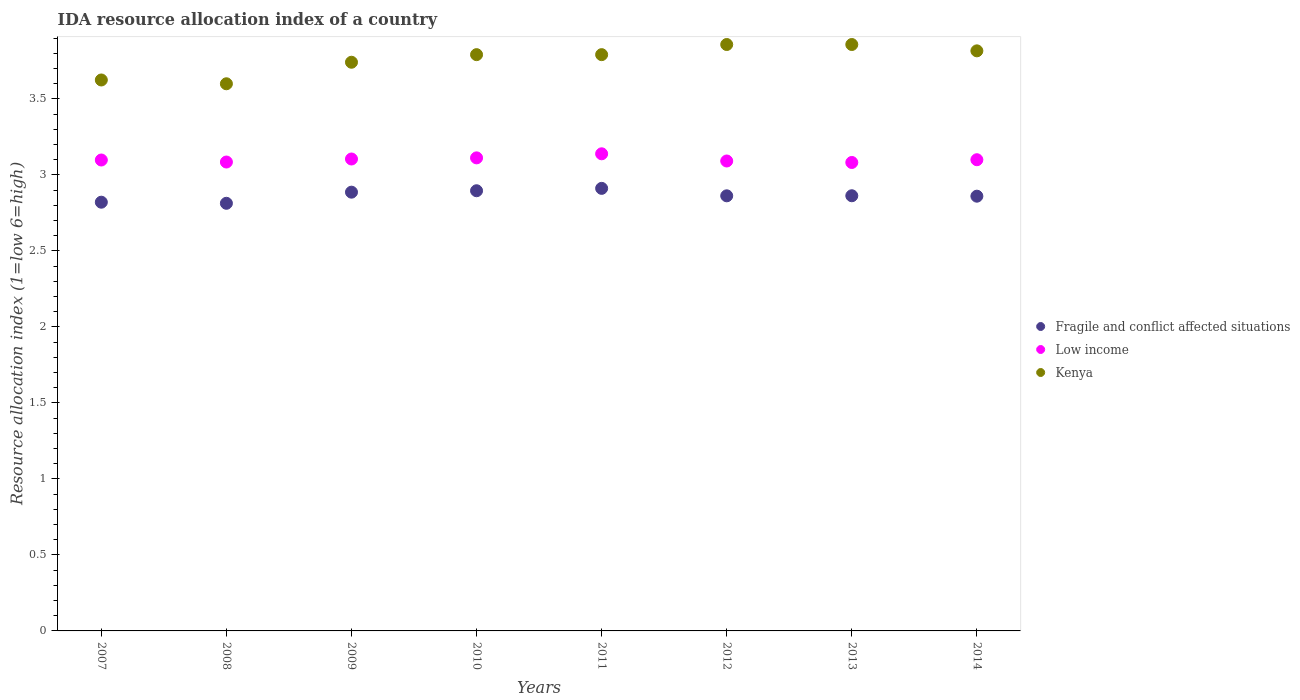How many different coloured dotlines are there?
Keep it short and to the point. 3. What is the IDA resource allocation index in Fragile and conflict affected situations in 2010?
Make the answer very short. 2.9. Across all years, what is the maximum IDA resource allocation index in Low income?
Keep it short and to the point. 3.14. Across all years, what is the minimum IDA resource allocation index in Low income?
Your answer should be compact. 3.08. In which year was the IDA resource allocation index in Kenya maximum?
Offer a terse response. 2012. In which year was the IDA resource allocation index in Kenya minimum?
Offer a terse response. 2008. What is the total IDA resource allocation index in Kenya in the graph?
Provide a short and direct response. 30.08. What is the difference between the IDA resource allocation index in Low income in 2008 and that in 2014?
Your answer should be very brief. -0.02. What is the difference between the IDA resource allocation index in Fragile and conflict affected situations in 2014 and the IDA resource allocation index in Kenya in 2012?
Make the answer very short. -1. What is the average IDA resource allocation index in Low income per year?
Keep it short and to the point. 3.1. In the year 2013, what is the difference between the IDA resource allocation index in Low income and IDA resource allocation index in Fragile and conflict affected situations?
Ensure brevity in your answer.  0.22. What is the ratio of the IDA resource allocation index in Kenya in 2009 to that in 2012?
Give a very brief answer. 0.97. What is the difference between the highest and the second highest IDA resource allocation index in Fragile and conflict affected situations?
Give a very brief answer. 0.02. What is the difference between the highest and the lowest IDA resource allocation index in Fragile and conflict affected situations?
Your answer should be very brief. 0.1. Is the sum of the IDA resource allocation index in Fragile and conflict affected situations in 2007 and 2013 greater than the maximum IDA resource allocation index in Kenya across all years?
Keep it short and to the point. Yes. Does the IDA resource allocation index in Fragile and conflict affected situations monotonically increase over the years?
Your response must be concise. No. Is the IDA resource allocation index in Fragile and conflict affected situations strictly greater than the IDA resource allocation index in Low income over the years?
Offer a very short reply. No. Is the IDA resource allocation index in Low income strictly less than the IDA resource allocation index in Kenya over the years?
Give a very brief answer. Yes. How many years are there in the graph?
Keep it short and to the point. 8. What is the difference between two consecutive major ticks on the Y-axis?
Your answer should be very brief. 0.5. Are the values on the major ticks of Y-axis written in scientific E-notation?
Provide a succinct answer. No. Does the graph contain any zero values?
Your answer should be very brief. No. Where does the legend appear in the graph?
Offer a terse response. Center right. What is the title of the graph?
Offer a terse response. IDA resource allocation index of a country. Does "Lesotho" appear as one of the legend labels in the graph?
Provide a succinct answer. No. What is the label or title of the X-axis?
Your response must be concise. Years. What is the label or title of the Y-axis?
Offer a terse response. Resource allocation index (1=low 6=high). What is the Resource allocation index (1=low 6=high) of Fragile and conflict affected situations in 2007?
Your answer should be very brief. 2.82. What is the Resource allocation index (1=low 6=high) in Low income in 2007?
Offer a very short reply. 3.1. What is the Resource allocation index (1=low 6=high) in Kenya in 2007?
Keep it short and to the point. 3.62. What is the Resource allocation index (1=low 6=high) of Fragile and conflict affected situations in 2008?
Offer a very short reply. 2.81. What is the Resource allocation index (1=low 6=high) in Low income in 2008?
Provide a short and direct response. 3.09. What is the Resource allocation index (1=low 6=high) of Fragile and conflict affected situations in 2009?
Keep it short and to the point. 2.89. What is the Resource allocation index (1=low 6=high) of Low income in 2009?
Make the answer very short. 3.11. What is the Resource allocation index (1=low 6=high) of Kenya in 2009?
Provide a succinct answer. 3.74. What is the Resource allocation index (1=low 6=high) of Fragile and conflict affected situations in 2010?
Ensure brevity in your answer.  2.9. What is the Resource allocation index (1=low 6=high) of Low income in 2010?
Provide a short and direct response. 3.11. What is the Resource allocation index (1=low 6=high) of Kenya in 2010?
Offer a terse response. 3.79. What is the Resource allocation index (1=low 6=high) in Fragile and conflict affected situations in 2011?
Give a very brief answer. 2.91. What is the Resource allocation index (1=low 6=high) of Low income in 2011?
Make the answer very short. 3.14. What is the Resource allocation index (1=low 6=high) of Kenya in 2011?
Your response must be concise. 3.79. What is the Resource allocation index (1=low 6=high) in Fragile and conflict affected situations in 2012?
Provide a short and direct response. 2.86. What is the Resource allocation index (1=low 6=high) of Low income in 2012?
Keep it short and to the point. 3.09. What is the Resource allocation index (1=low 6=high) in Kenya in 2012?
Offer a very short reply. 3.86. What is the Resource allocation index (1=low 6=high) in Fragile and conflict affected situations in 2013?
Keep it short and to the point. 2.86. What is the Resource allocation index (1=low 6=high) of Low income in 2013?
Provide a succinct answer. 3.08. What is the Resource allocation index (1=low 6=high) of Kenya in 2013?
Your response must be concise. 3.86. What is the Resource allocation index (1=low 6=high) of Fragile and conflict affected situations in 2014?
Keep it short and to the point. 2.86. What is the Resource allocation index (1=low 6=high) in Low income in 2014?
Your answer should be compact. 3.1. What is the Resource allocation index (1=low 6=high) of Kenya in 2014?
Give a very brief answer. 3.82. Across all years, what is the maximum Resource allocation index (1=low 6=high) in Fragile and conflict affected situations?
Offer a very short reply. 2.91. Across all years, what is the maximum Resource allocation index (1=low 6=high) in Low income?
Provide a succinct answer. 3.14. Across all years, what is the maximum Resource allocation index (1=low 6=high) in Kenya?
Your answer should be compact. 3.86. Across all years, what is the minimum Resource allocation index (1=low 6=high) of Fragile and conflict affected situations?
Give a very brief answer. 2.81. Across all years, what is the minimum Resource allocation index (1=low 6=high) of Low income?
Keep it short and to the point. 3.08. What is the total Resource allocation index (1=low 6=high) in Fragile and conflict affected situations in the graph?
Provide a short and direct response. 22.92. What is the total Resource allocation index (1=low 6=high) in Low income in the graph?
Keep it short and to the point. 24.81. What is the total Resource allocation index (1=low 6=high) of Kenya in the graph?
Your response must be concise. 30.08. What is the difference between the Resource allocation index (1=low 6=high) of Fragile and conflict affected situations in 2007 and that in 2008?
Offer a very short reply. 0.01. What is the difference between the Resource allocation index (1=low 6=high) of Low income in 2007 and that in 2008?
Your response must be concise. 0.01. What is the difference between the Resource allocation index (1=low 6=high) of Kenya in 2007 and that in 2008?
Your response must be concise. 0.03. What is the difference between the Resource allocation index (1=low 6=high) in Fragile and conflict affected situations in 2007 and that in 2009?
Keep it short and to the point. -0.07. What is the difference between the Resource allocation index (1=low 6=high) of Low income in 2007 and that in 2009?
Provide a short and direct response. -0.01. What is the difference between the Resource allocation index (1=low 6=high) in Kenya in 2007 and that in 2009?
Your answer should be very brief. -0.12. What is the difference between the Resource allocation index (1=low 6=high) in Fragile and conflict affected situations in 2007 and that in 2010?
Provide a short and direct response. -0.08. What is the difference between the Resource allocation index (1=low 6=high) in Low income in 2007 and that in 2010?
Your answer should be compact. -0.01. What is the difference between the Resource allocation index (1=low 6=high) of Kenya in 2007 and that in 2010?
Ensure brevity in your answer.  -0.17. What is the difference between the Resource allocation index (1=low 6=high) in Fragile and conflict affected situations in 2007 and that in 2011?
Your answer should be compact. -0.09. What is the difference between the Resource allocation index (1=low 6=high) of Low income in 2007 and that in 2011?
Provide a short and direct response. -0.04. What is the difference between the Resource allocation index (1=low 6=high) of Fragile and conflict affected situations in 2007 and that in 2012?
Provide a succinct answer. -0.04. What is the difference between the Resource allocation index (1=low 6=high) in Low income in 2007 and that in 2012?
Your answer should be very brief. 0.01. What is the difference between the Resource allocation index (1=low 6=high) in Kenya in 2007 and that in 2012?
Give a very brief answer. -0.23. What is the difference between the Resource allocation index (1=low 6=high) in Fragile and conflict affected situations in 2007 and that in 2013?
Offer a very short reply. -0.04. What is the difference between the Resource allocation index (1=low 6=high) of Low income in 2007 and that in 2013?
Your response must be concise. 0.02. What is the difference between the Resource allocation index (1=low 6=high) in Kenya in 2007 and that in 2013?
Give a very brief answer. -0.23. What is the difference between the Resource allocation index (1=low 6=high) of Fragile and conflict affected situations in 2007 and that in 2014?
Provide a short and direct response. -0.04. What is the difference between the Resource allocation index (1=low 6=high) of Low income in 2007 and that in 2014?
Offer a terse response. -0. What is the difference between the Resource allocation index (1=low 6=high) in Kenya in 2007 and that in 2014?
Keep it short and to the point. -0.19. What is the difference between the Resource allocation index (1=low 6=high) of Fragile and conflict affected situations in 2008 and that in 2009?
Your answer should be compact. -0.07. What is the difference between the Resource allocation index (1=low 6=high) of Low income in 2008 and that in 2009?
Make the answer very short. -0.02. What is the difference between the Resource allocation index (1=low 6=high) of Kenya in 2008 and that in 2009?
Offer a very short reply. -0.14. What is the difference between the Resource allocation index (1=low 6=high) in Fragile and conflict affected situations in 2008 and that in 2010?
Your answer should be very brief. -0.08. What is the difference between the Resource allocation index (1=low 6=high) in Low income in 2008 and that in 2010?
Offer a very short reply. -0.03. What is the difference between the Resource allocation index (1=low 6=high) in Kenya in 2008 and that in 2010?
Provide a succinct answer. -0.19. What is the difference between the Resource allocation index (1=low 6=high) in Fragile and conflict affected situations in 2008 and that in 2011?
Your answer should be compact. -0.1. What is the difference between the Resource allocation index (1=low 6=high) in Low income in 2008 and that in 2011?
Keep it short and to the point. -0.05. What is the difference between the Resource allocation index (1=low 6=high) in Kenya in 2008 and that in 2011?
Give a very brief answer. -0.19. What is the difference between the Resource allocation index (1=low 6=high) of Fragile and conflict affected situations in 2008 and that in 2012?
Provide a short and direct response. -0.05. What is the difference between the Resource allocation index (1=low 6=high) in Low income in 2008 and that in 2012?
Provide a short and direct response. -0.01. What is the difference between the Resource allocation index (1=low 6=high) in Kenya in 2008 and that in 2012?
Make the answer very short. -0.26. What is the difference between the Resource allocation index (1=low 6=high) of Fragile and conflict affected situations in 2008 and that in 2013?
Keep it short and to the point. -0.05. What is the difference between the Resource allocation index (1=low 6=high) in Low income in 2008 and that in 2013?
Provide a succinct answer. 0. What is the difference between the Resource allocation index (1=low 6=high) in Kenya in 2008 and that in 2013?
Your answer should be compact. -0.26. What is the difference between the Resource allocation index (1=low 6=high) in Fragile and conflict affected situations in 2008 and that in 2014?
Make the answer very short. -0.05. What is the difference between the Resource allocation index (1=low 6=high) of Low income in 2008 and that in 2014?
Provide a succinct answer. -0.02. What is the difference between the Resource allocation index (1=low 6=high) of Kenya in 2008 and that in 2014?
Give a very brief answer. -0.22. What is the difference between the Resource allocation index (1=low 6=high) of Fragile and conflict affected situations in 2009 and that in 2010?
Keep it short and to the point. -0.01. What is the difference between the Resource allocation index (1=low 6=high) of Low income in 2009 and that in 2010?
Offer a terse response. -0.01. What is the difference between the Resource allocation index (1=low 6=high) of Kenya in 2009 and that in 2010?
Your answer should be compact. -0.05. What is the difference between the Resource allocation index (1=low 6=high) in Fragile and conflict affected situations in 2009 and that in 2011?
Keep it short and to the point. -0.03. What is the difference between the Resource allocation index (1=low 6=high) of Low income in 2009 and that in 2011?
Offer a very short reply. -0.03. What is the difference between the Resource allocation index (1=low 6=high) in Kenya in 2009 and that in 2011?
Give a very brief answer. -0.05. What is the difference between the Resource allocation index (1=low 6=high) of Fragile and conflict affected situations in 2009 and that in 2012?
Your answer should be compact. 0.02. What is the difference between the Resource allocation index (1=low 6=high) of Low income in 2009 and that in 2012?
Provide a succinct answer. 0.01. What is the difference between the Resource allocation index (1=low 6=high) in Kenya in 2009 and that in 2012?
Your response must be concise. -0.12. What is the difference between the Resource allocation index (1=low 6=high) in Fragile and conflict affected situations in 2009 and that in 2013?
Offer a terse response. 0.02. What is the difference between the Resource allocation index (1=low 6=high) of Low income in 2009 and that in 2013?
Your answer should be compact. 0.02. What is the difference between the Resource allocation index (1=low 6=high) of Kenya in 2009 and that in 2013?
Your response must be concise. -0.12. What is the difference between the Resource allocation index (1=low 6=high) of Fragile and conflict affected situations in 2009 and that in 2014?
Offer a terse response. 0.03. What is the difference between the Resource allocation index (1=low 6=high) of Low income in 2009 and that in 2014?
Make the answer very short. 0. What is the difference between the Resource allocation index (1=low 6=high) of Kenya in 2009 and that in 2014?
Offer a terse response. -0.07. What is the difference between the Resource allocation index (1=low 6=high) in Fragile and conflict affected situations in 2010 and that in 2011?
Ensure brevity in your answer.  -0.02. What is the difference between the Resource allocation index (1=low 6=high) in Low income in 2010 and that in 2011?
Make the answer very short. -0.03. What is the difference between the Resource allocation index (1=low 6=high) of Fragile and conflict affected situations in 2010 and that in 2012?
Give a very brief answer. 0.03. What is the difference between the Resource allocation index (1=low 6=high) of Low income in 2010 and that in 2012?
Provide a succinct answer. 0.02. What is the difference between the Resource allocation index (1=low 6=high) in Kenya in 2010 and that in 2012?
Provide a succinct answer. -0.07. What is the difference between the Resource allocation index (1=low 6=high) of Fragile and conflict affected situations in 2010 and that in 2013?
Keep it short and to the point. 0.03. What is the difference between the Resource allocation index (1=low 6=high) of Low income in 2010 and that in 2013?
Offer a terse response. 0.03. What is the difference between the Resource allocation index (1=low 6=high) of Kenya in 2010 and that in 2013?
Ensure brevity in your answer.  -0.07. What is the difference between the Resource allocation index (1=low 6=high) of Fragile and conflict affected situations in 2010 and that in 2014?
Your response must be concise. 0.04. What is the difference between the Resource allocation index (1=low 6=high) of Low income in 2010 and that in 2014?
Make the answer very short. 0.01. What is the difference between the Resource allocation index (1=low 6=high) in Kenya in 2010 and that in 2014?
Make the answer very short. -0.03. What is the difference between the Resource allocation index (1=low 6=high) in Fragile and conflict affected situations in 2011 and that in 2012?
Keep it short and to the point. 0.05. What is the difference between the Resource allocation index (1=low 6=high) in Low income in 2011 and that in 2012?
Offer a very short reply. 0.05. What is the difference between the Resource allocation index (1=low 6=high) in Kenya in 2011 and that in 2012?
Offer a terse response. -0.07. What is the difference between the Resource allocation index (1=low 6=high) of Fragile and conflict affected situations in 2011 and that in 2013?
Provide a short and direct response. 0.05. What is the difference between the Resource allocation index (1=low 6=high) in Low income in 2011 and that in 2013?
Your response must be concise. 0.06. What is the difference between the Resource allocation index (1=low 6=high) of Kenya in 2011 and that in 2013?
Offer a very short reply. -0.07. What is the difference between the Resource allocation index (1=low 6=high) of Fragile and conflict affected situations in 2011 and that in 2014?
Offer a terse response. 0.05. What is the difference between the Resource allocation index (1=low 6=high) in Low income in 2011 and that in 2014?
Your answer should be compact. 0.04. What is the difference between the Resource allocation index (1=low 6=high) of Kenya in 2011 and that in 2014?
Keep it short and to the point. -0.03. What is the difference between the Resource allocation index (1=low 6=high) of Fragile and conflict affected situations in 2012 and that in 2013?
Offer a terse response. -0. What is the difference between the Resource allocation index (1=low 6=high) in Low income in 2012 and that in 2013?
Give a very brief answer. 0.01. What is the difference between the Resource allocation index (1=low 6=high) in Kenya in 2012 and that in 2013?
Give a very brief answer. 0. What is the difference between the Resource allocation index (1=low 6=high) in Fragile and conflict affected situations in 2012 and that in 2014?
Provide a short and direct response. 0. What is the difference between the Resource allocation index (1=low 6=high) of Low income in 2012 and that in 2014?
Keep it short and to the point. -0.01. What is the difference between the Resource allocation index (1=low 6=high) in Kenya in 2012 and that in 2014?
Make the answer very short. 0.04. What is the difference between the Resource allocation index (1=low 6=high) in Fragile and conflict affected situations in 2013 and that in 2014?
Your answer should be compact. 0. What is the difference between the Resource allocation index (1=low 6=high) in Low income in 2013 and that in 2014?
Provide a succinct answer. -0.02. What is the difference between the Resource allocation index (1=low 6=high) in Kenya in 2013 and that in 2014?
Provide a short and direct response. 0.04. What is the difference between the Resource allocation index (1=low 6=high) of Fragile and conflict affected situations in 2007 and the Resource allocation index (1=low 6=high) of Low income in 2008?
Make the answer very short. -0.26. What is the difference between the Resource allocation index (1=low 6=high) of Fragile and conflict affected situations in 2007 and the Resource allocation index (1=low 6=high) of Kenya in 2008?
Offer a very short reply. -0.78. What is the difference between the Resource allocation index (1=low 6=high) in Low income in 2007 and the Resource allocation index (1=low 6=high) in Kenya in 2008?
Provide a short and direct response. -0.5. What is the difference between the Resource allocation index (1=low 6=high) in Fragile and conflict affected situations in 2007 and the Resource allocation index (1=low 6=high) in Low income in 2009?
Ensure brevity in your answer.  -0.28. What is the difference between the Resource allocation index (1=low 6=high) in Fragile and conflict affected situations in 2007 and the Resource allocation index (1=low 6=high) in Kenya in 2009?
Keep it short and to the point. -0.92. What is the difference between the Resource allocation index (1=low 6=high) in Low income in 2007 and the Resource allocation index (1=low 6=high) in Kenya in 2009?
Give a very brief answer. -0.64. What is the difference between the Resource allocation index (1=low 6=high) of Fragile and conflict affected situations in 2007 and the Resource allocation index (1=low 6=high) of Low income in 2010?
Make the answer very short. -0.29. What is the difference between the Resource allocation index (1=low 6=high) of Fragile and conflict affected situations in 2007 and the Resource allocation index (1=low 6=high) of Kenya in 2010?
Offer a very short reply. -0.97. What is the difference between the Resource allocation index (1=low 6=high) in Low income in 2007 and the Resource allocation index (1=low 6=high) in Kenya in 2010?
Provide a succinct answer. -0.69. What is the difference between the Resource allocation index (1=low 6=high) of Fragile and conflict affected situations in 2007 and the Resource allocation index (1=low 6=high) of Low income in 2011?
Keep it short and to the point. -0.32. What is the difference between the Resource allocation index (1=low 6=high) in Fragile and conflict affected situations in 2007 and the Resource allocation index (1=low 6=high) in Kenya in 2011?
Make the answer very short. -0.97. What is the difference between the Resource allocation index (1=low 6=high) of Low income in 2007 and the Resource allocation index (1=low 6=high) of Kenya in 2011?
Keep it short and to the point. -0.69. What is the difference between the Resource allocation index (1=low 6=high) in Fragile and conflict affected situations in 2007 and the Resource allocation index (1=low 6=high) in Low income in 2012?
Provide a short and direct response. -0.27. What is the difference between the Resource allocation index (1=low 6=high) in Fragile and conflict affected situations in 2007 and the Resource allocation index (1=low 6=high) in Kenya in 2012?
Offer a very short reply. -1.04. What is the difference between the Resource allocation index (1=low 6=high) in Low income in 2007 and the Resource allocation index (1=low 6=high) in Kenya in 2012?
Your answer should be very brief. -0.76. What is the difference between the Resource allocation index (1=low 6=high) in Fragile and conflict affected situations in 2007 and the Resource allocation index (1=low 6=high) in Low income in 2013?
Provide a succinct answer. -0.26. What is the difference between the Resource allocation index (1=low 6=high) of Fragile and conflict affected situations in 2007 and the Resource allocation index (1=low 6=high) of Kenya in 2013?
Keep it short and to the point. -1.04. What is the difference between the Resource allocation index (1=low 6=high) in Low income in 2007 and the Resource allocation index (1=low 6=high) in Kenya in 2013?
Keep it short and to the point. -0.76. What is the difference between the Resource allocation index (1=low 6=high) in Fragile and conflict affected situations in 2007 and the Resource allocation index (1=low 6=high) in Low income in 2014?
Ensure brevity in your answer.  -0.28. What is the difference between the Resource allocation index (1=low 6=high) in Fragile and conflict affected situations in 2007 and the Resource allocation index (1=low 6=high) in Kenya in 2014?
Provide a short and direct response. -1. What is the difference between the Resource allocation index (1=low 6=high) in Low income in 2007 and the Resource allocation index (1=low 6=high) in Kenya in 2014?
Your response must be concise. -0.72. What is the difference between the Resource allocation index (1=low 6=high) of Fragile and conflict affected situations in 2008 and the Resource allocation index (1=low 6=high) of Low income in 2009?
Offer a terse response. -0.29. What is the difference between the Resource allocation index (1=low 6=high) of Fragile and conflict affected situations in 2008 and the Resource allocation index (1=low 6=high) of Kenya in 2009?
Your answer should be compact. -0.93. What is the difference between the Resource allocation index (1=low 6=high) in Low income in 2008 and the Resource allocation index (1=low 6=high) in Kenya in 2009?
Your answer should be compact. -0.66. What is the difference between the Resource allocation index (1=low 6=high) of Fragile and conflict affected situations in 2008 and the Resource allocation index (1=low 6=high) of Low income in 2010?
Your answer should be compact. -0.3. What is the difference between the Resource allocation index (1=low 6=high) of Fragile and conflict affected situations in 2008 and the Resource allocation index (1=low 6=high) of Kenya in 2010?
Keep it short and to the point. -0.98. What is the difference between the Resource allocation index (1=low 6=high) of Low income in 2008 and the Resource allocation index (1=low 6=high) of Kenya in 2010?
Offer a very short reply. -0.71. What is the difference between the Resource allocation index (1=low 6=high) in Fragile and conflict affected situations in 2008 and the Resource allocation index (1=low 6=high) in Low income in 2011?
Offer a very short reply. -0.33. What is the difference between the Resource allocation index (1=low 6=high) of Fragile and conflict affected situations in 2008 and the Resource allocation index (1=low 6=high) of Kenya in 2011?
Give a very brief answer. -0.98. What is the difference between the Resource allocation index (1=low 6=high) of Low income in 2008 and the Resource allocation index (1=low 6=high) of Kenya in 2011?
Provide a short and direct response. -0.71. What is the difference between the Resource allocation index (1=low 6=high) of Fragile and conflict affected situations in 2008 and the Resource allocation index (1=low 6=high) of Low income in 2012?
Keep it short and to the point. -0.28. What is the difference between the Resource allocation index (1=low 6=high) in Fragile and conflict affected situations in 2008 and the Resource allocation index (1=low 6=high) in Kenya in 2012?
Keep it short and to the point. -1.04. What is the difference between the Resource allocation index (1=low 6=high) of Low income in 2008 and the Resource allocation index (1=low 6=high) of Kenya in 2012?
Provide a short and direct response. -0.77. What is the difference between the Resource allocation index (1=low 6=high) of Fragile and conflict affected situations in 2008 and the Resource allocation index (1=low 6=high) of Low income in 2013?
Keep it short and to the point. -0.27. What is the difference between the Resource allocation index (1=low 6=high) in Fragile and conflict affected situations in 2008 and the Resource allocation index (1=low 6=high) in Kenya in 2013?
Give a very brief answer. -1.04. What is the difference between the Resource allocation index (1=low 6=high) of Low income in 2008 and the Resource allocation index (1=low 6=high) of Kenya in 2013?
Offer a terse response. -0.77. What is the difference between the Resource allocation index (1=low 6=high) of Fragile and conflict affected situations in 2008 and the Resource allocation index (1=low 6=high) of Low income in 2014?
Provide a succinct answer. -0.29. What is the difference between the Resource allocation index (1=low 6=high) in Fragile and conflict affected situations in 2008 and the Resource allocation index (1=low 6=high) in Kenya in 2014?
Give a very brief answer. -1. What is the difference between the Resource allocation index (1=low 6=high) in Low income in 2008 and the Resource allocation index (1=low 6=high) in Kenya in 2014?
Give a very brief answer. -0.73. What is the difference between the Resource allocation index (1=low 6=high) of Fragile and conflict affected situations in 2009 and the Resource allocation index (1=low 6=high) of Low income in 2010?
Give a very brief answer. -0.23. What is the difference between the Resource allocation index (1=low 6=high) in Fragile and conflict affected situations in 2009 and the Resource allocation index (1=low 6=high) in Kenya in 2010?
Provide a short and direct response. -0.9. What is the difference between the Resource allocation index (1=low 6=high) of Low income in 2009 and the Resource allocation index (1=low 6=high) of Kenya in 2010?
Keep it short and to the point. -0.69. What is the difference between the Resource allocation index (1=low 6=high) of Fragile and conflict affected situations in 2009 and the Resource allocation index (1=low 6=high) of Low income in 2011?
Make the answer very short. -0.25. What is the difference between the Resource allocation index (1=low 6=high) in Fragile and conflict affected situations in 2009 and the Resource allocation index (1=low 6=high) in Kenya in 2011?
Provide a short and direct response. -0.9. What is the difference between the Resource allocation index (1=low 6=high) in Low income in 2009 and the Resource allocation index (1=low 6=high) in Kenya in 2011?
Your answer should be compact. -0.69. What is the difference between the Resource allocation index (1=low 6=high) of Fragile and conflict affected situations in 2009 and the Resource allocation index (1=low 6=high) of Low income in 2012?
Ensure brevity in your answer.  -0.21. What is the difference between the Resource allocation index (1=low 6=high) of Fragile and conflict affected situations in 2009 and the Resource allocation index (1=low 6=high) of Kenya in 2012?
Provide a succinct answer. -0.97. What is the difference between the Resource allocation index (1=low 6=high) of Low income in 2009 and the Resource allocation index (1=low 6=high) of Kenya in 2012?
Offer a very short reply. -0.75. What is the difference between the Resource allocation index (1=low 6=high) of Fragile and conflict affected situations in 2009 and the Resource allocation index (1=low 6=high) of Low income in 2013?
Keep it short and to the point. -0.2. What is the difference between the Resource allocation index (1=low 6=high) of Fragile and conflict affected situations in 2009 and the Resource allocation index (1=low 6=high) of Kenya in 2013?
Your answer should be very brief. -0.97. What is the difference between the Resource allocation index (1=low 6=high) of Low income in 2009 and the Resource allocation index (1=low 6=high) of Kenya in 2013?
Ensure brevity in your answer.  -0.75. What is the difference between the Resource allocation index (1=low 6=high) in Fragile and conflict affected situations in 2009 and the Resource allocation index (1=low 6=high) in Low income in 2014?
Ensure brevity in your answer.  -0.21. What is the difference between the Resource allocation index (1=low 6=high) of Fragile and conflict affected situations in 2009 and the Resource allocation index (1=low 6=high) of Kenya in 2014?
Your response must be concise. -0.93. What is the difference between the Resource allocation index (1=low 6=high) of Low income in 2009 and the Resource allocation index (1=low 6=high) of Kenya in 2014?
Provide a succinct answer. -0.71. What is the difference between the Resource allocation index (1=low 6=high) of Fragile and conflict affected situations in 2010 and the Resource allocation index (1=low 6=high) of Low income in 2011?
Your answer should be very brief. -0.24. What is the difference between the Resource allocation index (1=low 6=high) in Fragile and conflict affected situations in 2010 and the Resource allocation index (1=low 6=high) in Kenya in 2011?
Provide a succinct answer. -0.9. What is the difference between the Resource allocation index (1=low 6=high) of Low income in 2010 and the Resource allocation index (1=low 6=high) of Kenya in 2011?
Your answer should be very brief. -0.68. What is the difference between the Resource allocation index (1=low 6=high) of Fragile and conflict affected situations in 2010 and the Resource allocation index (1=low 6=high) of Low income in 2012?
Provide a succinct answer. -0.2. What is the difference between the Resource allocation index (1=low 6=high) in Fragile and conflict affected situations in 2010 and the Resource allocation index (1=low 6=high) in Kenya in 2012?
Your response must be concise. -0.96. What is the difference between the Resource allocation index (1=low 6=high) of Low income in 2010 and the Resource allocation index (1=low 6=high) of Kenya in 2012?
Provide a short and direct response. -0.75. What is the difference between the Resource allocation index (1=low 6=high) in Fragile and conflict affected situations in 2010 and the Resource allocation index (1=low 6=high) in Low income in 2013?
Keep it short and to the point. -0.19. What is the difference between the Resource allocation index (1=low 6=high) of Fragile and conflict affected situations in 2010 and the Resource allocation index (1=low 6=high) of Kenya in 2013?
Offer a terse response. -0.96. What is the difference between the Resource allocation index (1=low 6=high) in Low income in 2010 and the Resource allocation index (1=low 6=high) in Kenya in 2013?
Offer a terse response. -0.75. What is the difference between the Resource allocation index (1=low 6=high) in Fragile and conflict affected situations in 2010 and the Resource allocation index (1=low 6=high) in Low income in 2014?
Give a very brief answer. -0.2. What is the difference between the Resource allocation index (1=low 6=high) in Fragile and conflict affected situations in 2010 and the Resource allocation index (1=low 6=high) in Kenya in 2014?
Offer a very short reply. -0.92. What is the difference between the Resource allocation index (1=low 6=high) in Low income in 2010 and the Resource allocation index (1=low 6=high) in Kenya in 2014?
Provide a short and direct response. -0.7. What is the difference between the Resource allocation index (1=low 6=high) of Fragile and conflict affected situations in 2011 and the Resource allocation index (1=low 6=high) of Low income in 2012?
Your answer should be compact. -0.18. What is the difference between the Resource allocation index (1=low 6=high) in Fragile and conflict affected situations in 2011 and the Resource allocation index (1=low 6=high) in Kenya in 2012?
Keep it short and to the point. -0.95. What is the difference between the Resource allocation index (1=low 6=high) in Low income in 2011 and the Resource allocation index (1=low 6=high) in Kenya in 2012?
Make the answer very short. -0.72. What is the difference between the Resource allocation index (1=low 6=high) in Fragile and conflict affected situations in 2011 and the Resource allocation index (1=low 6=high) in Low income in 2013?
Offer a terse response. -0.17. What is the difference between the Resource allocation index (1=low 6=high) of Fragile and conflict affected situations in 2011 and the Resource allocation index (1=low 6=high) of Kenya in 2013?
Offer a very short reply. -0.95. What is the difference between the Resource allocation index (1=low 6=high) of Low income in 2011 and the Resource allocation index (1=low 6=high) of Kenya in 2013?
Offer a terse response. -0.72. What is the difference between the Resource allocation index (1=low 6=high) in Fragile and conflict affected situations in 2011 and the Resource allocation index (1=low 6=high) in Low income in 2014?
Your response must be concise. -0.19. What is the difference between the Resource allocation index (1=low 6=high) in Fragile and conflict affected situations in 2011 and the Resource allocation index (1=low 6=high) in Kenya in 2014?
Make the answer very short. -0.9. What is the difference between the Resource allocation index (1=low 6=high) in Low income in 2011 and the Resource allocation index (1=low 6=high) in Kenya in 2014?
Keep it short and to the point. -0.68. What is the difference between the Resource allocation index (1=low 6=high) in Fragile and conflict affected situations in 2012 and the Resource allocation index (1=low 6=high) in Low income in 2013?
Make the answer very short. -0.22. What is the difference between the Resource allocation index (1=low 6=high) in Fragile and conflict affected situations in 2012 and the Resource allocation index (1=low 6=high) in Kenya in 2013?
Your answer should be very brief. -1. What is the difference between the Resource allocation index (1=low 6=high) in Low income in 2012 and the Resource allocation index (1=low 6=high) in Kenya in 2013?
Keep it short and to the point. -0.77. What is the difference between the Resource allocation index (1=low 6=high) of Fragile and conflict affected situations in 2012 and the Resource allocation index (1=low 6=high) of Low income in 2014?
Keep it short and to the point. -0.24. What is the difference between the Resource allocation index (1=low 6=high) of Fragile and conflict affected situations in 2012 and the Resource allocation index (1=low 6=high) of Kenya in 2014?
Offer a very short reply. -0.95. What is the difference between the Resource allocation index (1=low 6=high) in Low income in 2012 and the Resource allocation index (1=low 6=high) in Kenya in 2014?
Make the answer very short. -0.72. What is the difference between the Resource allocation index (1=low 6=high) of Fragile and conflict affected situations in 2013 and the Resource allocation index (1=low 6=high) of Low income in 2014?
Your response must be concise. -0.24. What is the difference between the Resource allocation index (1=low 6=high) of Fragile and conflict affected situations in 2013 and the Resource allocation index (1=low 6=high) of Kenya in 2014?
Your response must be concise. -0.95. What is the difference between the Resource allocation index (1=low 6=high) in Low income in 2013 and the Resource allocation index (1=low 6=high) in Kenya in 2014?
Give a very brief answer. -0.73. What is the average Resource allocation index (1=low 6=high) in Fragile and conflict affected situations per year?
Your answer should be very brief. 2.86. What is the average Resource allocation index (1=low 6=high) in Low income per year?
Your answer should be very brief. 3.1. What is the average Resource allocation index (1=low 6=high) of Kenya per year?
Your answer should be very brief. 3.76. In the year 2007, what is the difference between the Resource allocation index (1=low 6=high) of Fragile and conflict affected situations and Resource allocation index (1=low 6=high) of Low income?
Keep it short and to the point. -0.28. In the year 2007, what is the difference between the Resource allocation index (1=low 6=high) in Fragile and conflict affected situations and Resource allocation index (1=low 6=high) in Kenya?
Give a very brief answer. -0.8. In the year 2007, what is the difference between the Resource allocation index (1=low 6=high) in Low income and Resource allocation index (1=low 6=high) in Kenya?
Ensure brevity in your answer.  -0.53. In the year 2008, what is the difference between the Resource allocation index (1=low 6=high) in Fragile and conflict affected situations and Resource allocation index (1=low 6=high) in Low income?
Give a very brief answer. -0.27. In the year 2008, what is the difference between the Resource allocation index (1=low 6=high) of Fragile and conflict affected situations and Resource allocation index (1=low 6=high) of Kenya?
Your response must be concise. -0.79. In the year 2008, what is the difference between the Resource allocation index (1=low 6=high) in Low income and Resource allocation index (1=low 6=high) in Kenya?
Your answer should be compact. -0.51. In the year 2009, what is the difference between the Resource allocation index (1=low 6=high) of Fragile and conflict affected situations and Resource allocation index (1=low 6=high) of Low income?
Offer a terse response. -0.22. In the year 2009, what is the difference between the Resource allocation index (1=low 6=high) of Fragile and conflict affected situations and Resource allocation index (1=low 6=high) of Kenya?
Your response must be concise. -0.85. In the year 2009, what is the difference between the Resource allocation index (1=low 6=high) in Low income and Resource allocation index (1=low 6=high) in Kenya?
Provide a succinct answer. -0.64. In the year 2010, what is the difference between the Resource allocation index (1=low 6=high) in Fragile and conflict affected situations and Resource allocation index (1=low 6=high) in Low income?
Give a very brief answer. -0.22. In the year 2010, what is the difference between the Resource allocation index (1=low 6=high) of Fragile and conflict affected situations and Resource allocation index (1=low 6=high) of Kenya?
Offer a terse response. -0.9. In the year 2010, what is the difference between the Resource allocation index (1=low 6=high) of Low income and Resource allocation index (1=low 6=high) of Kenya?
Your answer should be very brief. -0.68. In the year 2011, what is the difference between the Resource allocation index (1=low 6=high) in Fragile and conflict affected situations and Resource allocation index (1=low 6=high) in Low income?
Provide a short and direct response. -0.23. In the year 2011, what is the difference between the Resource allocation index (1=low 6=high) in Fragile and conflict affected situations and Resource allocation index (1=low 6=high) in Kenya?
Your answer should be very brief. -0.88. In the year 2011, what is the difference between the Resource allocation index (1=low 6=high) in Low income and Resource allocation index (1=low 6=high) in Kenya?
Ensure brevity in your answer.  -0.65. In the year 2012, what is the difference between the Resource allocation index (1=low 6=high) in Fragile and conflict affected situations and Resource allocation index (1=low 6=high) in Low income?
Your answer should be compact. -0.23. In the year 2012, what is the difference between the Resource allocation index (1=low 6=high) of Fragile and conflict affected situations and Resource allocation index (1=low 6=high) of Kenya?
Your answer should be very brief. -1. In the year 2012, what is the difference between the Resource allocation index (1=low 6=high) of Low income and Resource allocation index (1=low 6=high) of Kenya?
Ensure brevity in your answer.  -0.77. In the year 2013, what is the difference between the Resource allocation index (1=low 6=high) of Fragile and conflict affected situations and Resource allocation index (1=low 6=high) of Low income?
Provide a short and direct response. -0.22. In the year 2013, what is the difference between the Resource allocation index (1=low 6=high) in Fragile and conflict affected situations and Resource allocation index (1=low 6=high) in Kenya?
Keep it short and to the point. -1. In the year 2013, what is the difference between the Resource allocation index (1=low 6=high) in Low income and Resource allocation index (1=low 6=high) in Kenya?
Your answer should be compact. -0.78. In the year 2014, what is the difference between the Resource allocation index (1=low 6=high) of Fragile and conflict affected situations and Resource allocation index (1=low 6=high) of Low income?
Ensure brevity in your answer.  -0.24. In the year 2014, what is the difference between the Resource allocation index (1=low 6=high) in Fragile and conflict affected situations and Resource allocation index (1=low 6=high) in Kenya?
Your answer should be very brief. -0.96. In the year 2014, what is the difference between the Resource allocation index (1=low 6=high) in Low income and Resource allocation index (1=low 6=high) in Kenya?
Give a very brief answer. -0.72. What is the ratio of the Resource allocation index (1=low 6=high) in Fragile and conflict affected situations in 2007 to that in 2009?
Ensure brevity in your answer.  0.98. What is the ratio of the Resource allocation index (1=low 6=high) in Low income in 2007 to that in 2009?
Provide a succinct answer. 1. What is the ratio of the Resource allocation index (1=low 6=high) of Kenya in 2007 to that in 2009?
Ensure brevity in your answer.  0.97. What is the ratio of the Resource allocation index (1=low 6=high) of Low income in 2007 to that in 2010?
Ensure brevity in your answer.  1. What is the ratio of the Resource allocation index (1=low 6=high) in Kenya in 2007 to that in 2010?
Keep it short and to the point. 0.96. What is the ratio of the Resource allocation index (1=low 6=high) of Fragile and conflict affected situations in 2007 to that in 2011?
Offer a terse response. 0.97. What is the ratio of the Resource allocation index (1=low 6=high) in Low income in 2007 to that in 2011?
Provide a succinct answer. 0.99. What is the ratio of the Resource allocation index (1=low 6=high) in Kenya in 2007 to that in 2011?
Your response must be concise. 0.96. What is the ratio of the Resource allocation index (1=low 6=high) in Fragile and conflict affected situations in 2007 to that in 2012?
Your response must be concise. 0.99. What is the ratio of the Resource allocation index (1=low 6=high) of Low income in 2007 to that in 2012?
Ensure brevity in your answer.  1. What is the ratio of the Resource allocation index (1=low 6=high) in Kenya in 2007 to that in 2012?
Offer a terse response. 0.94. What is the ratio of the Resource allocation index (1=low 6=high) of Fragile and conflict affected situations in 2007 to that in 2013?
Offer a very short reply. 0.99. What is the ratio of the Resource allocation index (1=low 6=high) of Low income in 2007 to that in 2013?
Provide a short and direct response. 1.01. What is the ratio of the Resource allocation index (1=low 6=high) in Kenya in 2007 to that in 2013?
Your answer should be very brief. 0.94. What is the ratio of the Resource allocation index (1=low 6=high) of Fragile and conflict affected situations in 2007 to that in 2014?
Provide a succinct answer. 0.99. What is the ratio of the Resource allocation index (1=low 6=high) in Kenya in 2007 to that in 2014?
Your response must be concise. 0.95. What is the ratio of the Resource allocation index (1=low 6=high) in Fragile and conflict affected situations in 2008 to that in 2009?
Provide a short and direct response. 0.97. What is the ratio of the Resource allocation index (1=low 6=high) in Kenya in 2008 to that in 2009?
Your answer should be very brief. 0.96. What is the ratio of the Resource allocation index (1=low 6=high) in Fragile and conflict affected situations in 2008 to that in 2010?
Your answer should be very brief. 0.97. What is the ratio of the Resource allocation index (1=low 6=high) of Low income in 2008 to that in 2010?
Give a very brief answer. 0.99. What is the ratio of the Resource allocation index (1=low 6=high) of Kenya in 2008 to that in 2010?
Keep it short and to the point. 0.95. What is the ratio of the Resource allocation index (1=low 6=high) of Fragile and conflict affected situations in 2008 to that in 2011?
Ensure brevity in your answer.  0.97. What is the ratio of the Resource allocation index (1=low 6=high) of Low income in 2008 to that in 2011?
Make the answer very short. 0.98. What is the ratio of the Resource allocation index (1=low 6=high) of Kenya in 2008 to that in 2011?
Keep it short and to the point. 0.95. What is the ratio of the Resource allocation index (1=low 6=high) of Fragile and conflict affected situations in 2008 to that in 2012?
Your response must be concise. 0.98. What is the ratio of the Resource allocation index (1=low 6=high) of Low income in 2008 to that in 2012?
Offer a very short reply. 1. What is the ratio of the Resource allocation index (1=low 6=high) in Kenya in 2008 to that in 2012?
Your answer should be very brief. 0.93. What is the ratio of the Resource allocation index (1=low 6=high) of Fragile and conflict affected situations in 2008 to that in 2013?
Give a very brief answer. 0.98. What is the ratio of the Resource allocation index (1=low 6=high) of Low income in 2008 to that in 2013?
Your response must be concise. 1. What is the ratio of the Resource allocation index (1=low 6=high) in Kenya in 2008 to that in 2013?
Offer a very short reply. 0.93. What is the ratio of the Resource allocation index (1=low 6=high) of Fragile and conflict affected situations in 2008 to that in 2014?
Make the answer very short. 0.98. What is the ratio of the Resource allocation index (1=low 6=high) of Kenya in 2008 to that in 2014?
Your answer should be compact. 0.94. What is the ratio of the Resource allocation index (1=low 6=high) in Kenya in 2009 to that in 2010?
Your response must be concise. 0.99. What is the ratio of the Resource allocation index (1=low 6=high) of Fragile and conflict affected situations in 2009 to that in 2011?
Make the answer very short. 0.99. What is the ratio of the Resource allocation index (1=low 6=high) of Fragile and conflict affected situations in 2009 to that in 2012?
Make the answer very short. 1.01. What is the ratio of the Resource allocation index (1=low 6=high) of Low income in 2009 to that in 2012?
Your answer should be compact. 1. What is the ratio of the Resource allocation index (1=low 6=high) in Kenya in 2009 to that in 2012?
Ensure brevity in your answer.  0.97. What is the ratio of the Resource allocation index (1=low 6=high) in Fragile and conflict affected situations in 2009 to that in 2013?
Make the answer very short. 1.01. What is the ratio of the Resource allocation index (1=low 6=high) of Low income in 2009 to that in 2013?
Your answer should be compact. 1.01. What is the ratio of the Resource allocation index (1=low 6=high) of Kenya in 2009 to that in 2013?
Provide a succinct answer. 0.97. What is the ratio of the Resource allocation index (1=low 6=high) of Fragile and conflict affected situations in 2009 to that in 2014?
Your response must be concise. 1.01. What is the ratio of the Resource allocation index (1=low 6=high) of Low income in 2009 to that in 2014?
Your response must be concise. 1. What is the ratio of the Resource allocation index (1=low 6=high) in Kenya in 2009 to that in 2014?
Your response must be concise. 0.98. What is the ratio of the Resource allocation index (1=low 6=high) in Fragile and conflict affected situations in 2010 to that in 2011?
Provide a short and direct response. 0.99. What is the ratio of the Resource allocation index (1=low 6=high) of Low income in 2010 to that in 2011?
Give a very brief answer. 0.99. What is the ratio of the Resource allocation index (1=low 6=high) of Kenya in 2010 to that in 2011?
Your response must be concise. 1. What is the ratio of the Resource allocation index (1=low 6=high) of Fragile and conflict affected situations in 2010 to that in 2012?
Make the answer very short. 1.01. What is the ratio of the Resource allocation index (1=low 6=high) in Low income in 2010 to that in 2012?
Offer a terse response. 1.01. What is the ratio of the Resource allocation index (1=low 6=high) in Kenya in 2010 to that in 2012?
Provide a short and direct response. 0.98. What is the ratio of the Resource allocation index (1=low 6=high) of Fragile and conflict affected situations in 2010 to that in 2013?
Provide a succinct answer. 1.01. What is the ratio of the Resource allocation index (1=low 6=high) in Low income in 2010 to that in 2013?
Make the answer very short. 1.01. What is the ratio of the Resource allocation index (1=low 6=high) of Kenya in 2010 to that in 2013?
Provide a short and direct response. 0.98. What is the ratio of the Resource allocation index (1=low 6=high) in Fragile and conflict affected situations in 2010 to that in 2014?
Provide a succinct answer. 1.01. What is the ratio of the Resource allocation index (1=low 6=high) of Kenya in 2010 to that in 2014?
Ensure brevity in your answer.  0.99. What is the ratio of the Resource allocation index (1=low 6=high) of Fragile and conflict affected situations in 2011 to that in 2012?
Your response must be concise. 1.02. What is the ratio of the Resource allocation index (1=low 6=high) in Low income in 2011 to that in 2012?
Your response must be concise. 1.02. What is the ratio of the Resource allocation index (1=low 6=high) of Kenya in 2011 to that in 2012?
Keep it short and to the point. 0.98. What is the ratio of the Resource allocation index (1=low 6=high) of Fragile and conflict affected situations in 2011 to that in 2013?
Your answer should be very brief. 1.02. What is the ratio of the Resource allocation index (1=low 6=high) in Low income in 2011 to that in 2013?
Make the answer very short. 1.02. What is the ratio of the Resource allocation index (1=low 6=high) in Kenya in 2011 to that in 2013?
Your answer should be compact. 0.98. What is the ratio of the Resource allocation index (1=low 6=high) of Low income in 2011 to that in 2014?
Offer a very short reply. 1.01. What is the ratio of the Resource allocation index (1=low 6=high) in Kenya in 2011 to that in 2014?
Offer a terse response. 0.99. What is the ratio of the Resource allocation index (1=low 6=high) of Fragile and conflict affected situations in 2012 to that in 2013?
Make the answer very short. 1. What is the ratio of the Resource allocation index (1=low 6=high) in Kenya in 2012 to that in 2013?
Offer a very short reply. 1. What is the ratio of the Resource allocation index (1=low 6=high) of Kenya in 2012 to that in 2014?
Keep it short and to the point. 1.01. What is the ratio of the Resource allocation index (1=low 6=high) in Fragile and conflict affected situations in 2013 to that in 2014?
Offer a very short reply. 1. What is the ratio of the Resource allocation index (1=low 6=high) of Low income in 2013 to that in 2014?
Offer a very short reply. 0.99. What is the ratio of the Resource allocation index (1=low 6=high) of Kenya in 2013 to that in 2014?
Provide a succinct answer. 1.01. What is the difference between the highest and the second highest Resource allocation index (1=low 6=high) in Fragile and conflict affected situations?
Offer a very short reply. 0.02. What is the difference between the highest and the second highest Resource allocation index (1=low 6=high) in Low income?
Ensure brevity in your answer.  0.03. What is the difference between the highest and the second highest Resource allocation index (1=low 6=high) of Kenya?
Your response must be concise. 0. What is the difference between the highest and the lowest Resource allocation index (1=low 6=high) in Fragile and conflict affected situations?
Your response must be concise. 0.1. What is the difference between the highest and the lowest Resource allocation index (1=low 6=high) in Low income?
Your answer should be compact. 0.06. What is the difference between the highest and the lowest Resource allocation index (1=low 6=high) in Kenya?
Offer a very short reply. 0.26. 